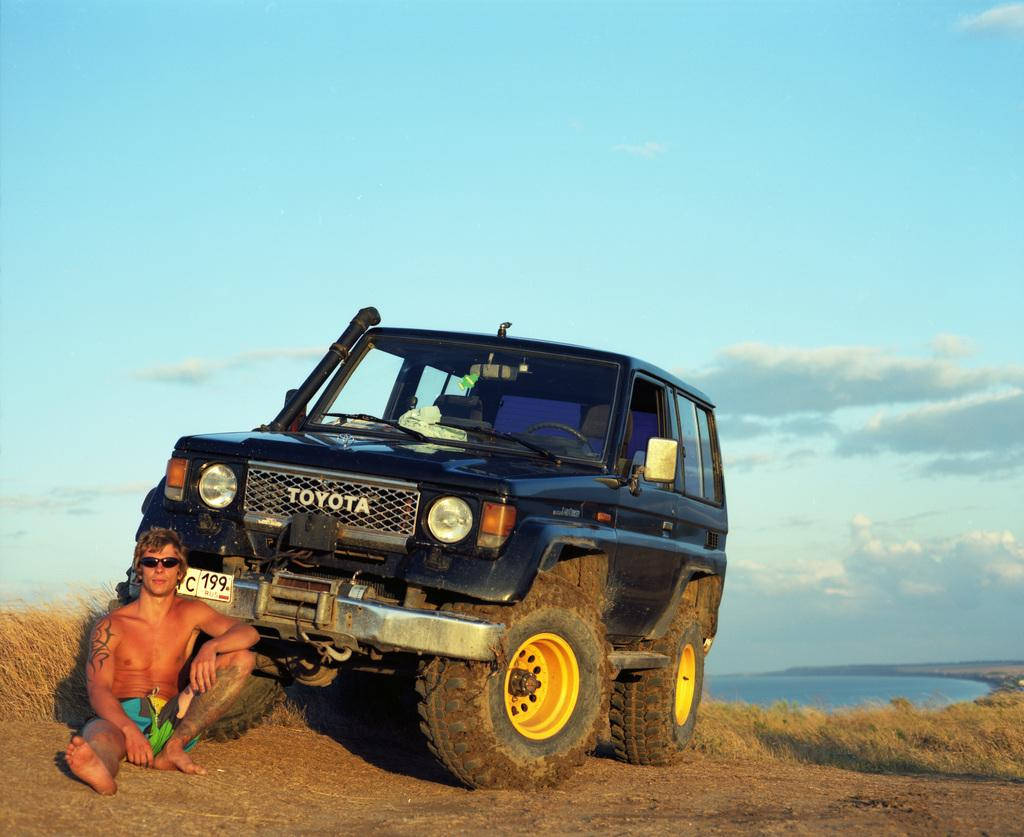What is the man in the image doing? The man is sitting on the ground in the image. What type of vehicle can be seen in the image? There is a black color car in the image. What type of terrain is visible in the image? There is grass visible in the image. What can be seen in the background of the image? The sky and water are visible in the background of the image. How many trucks are visible in the image? There are no trucks visible in the image. What color is the sand in the image? There is no sand present in the image. 